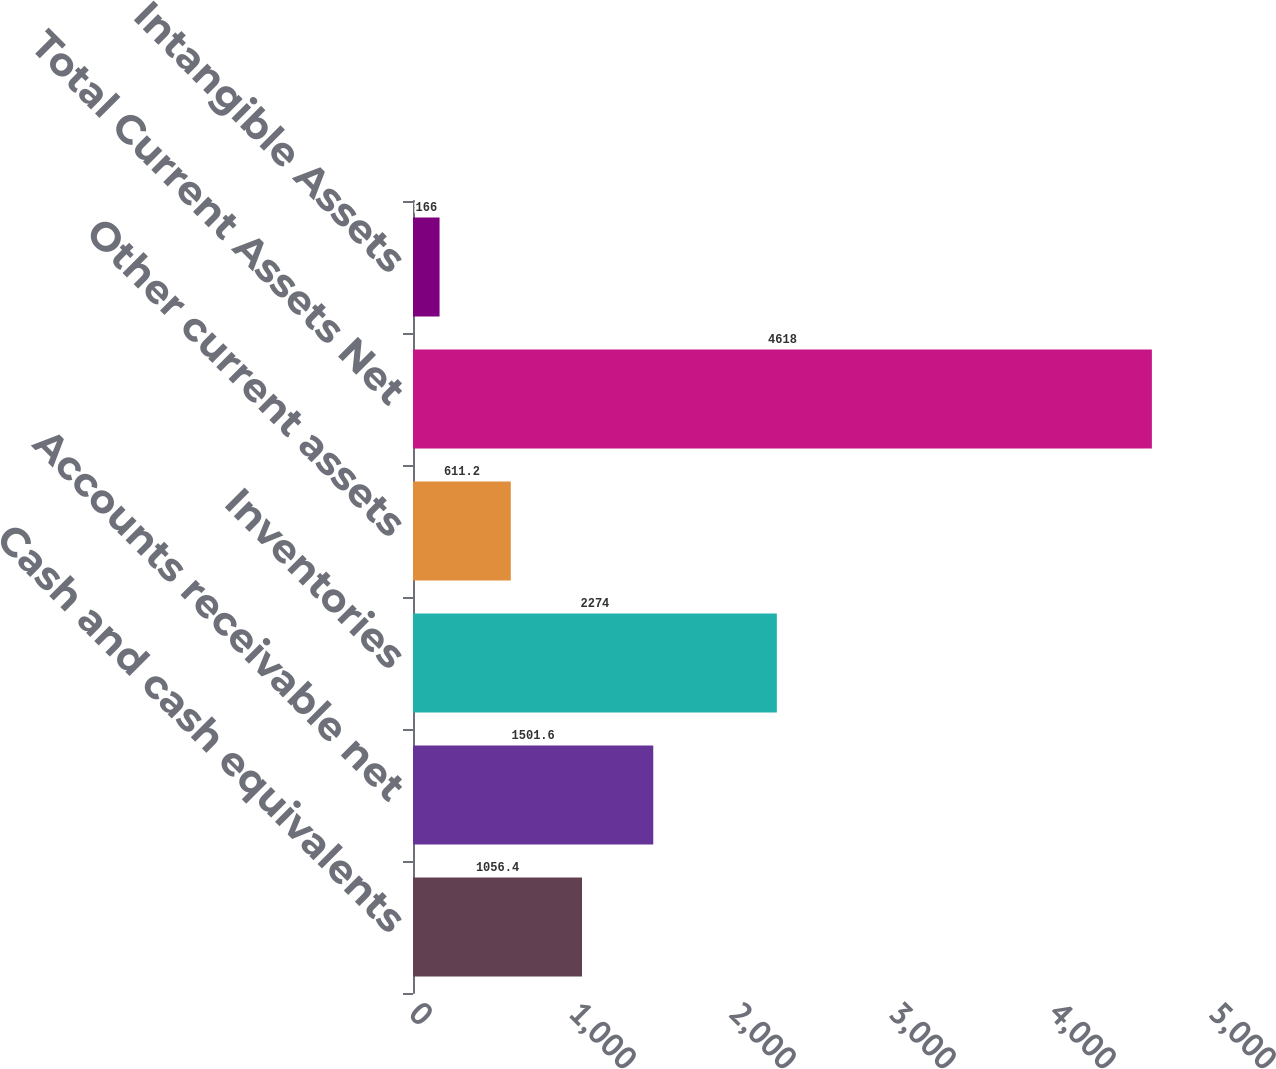<chart> <loc_0><loc_0><loc_500><loc_500><bar_chart><fcel>Cash and cash equivalents<fcel>Accounts receivable net<fcel>Inventories<fcel>Other current assets<fcel>Total Current Assets Net<fcel>Intangible Assets<nl><fcel>1056.4<fcel>1501.6<fcel>2274<fcel>611.2<fcel>4618<fcel>166<nl></chart> 